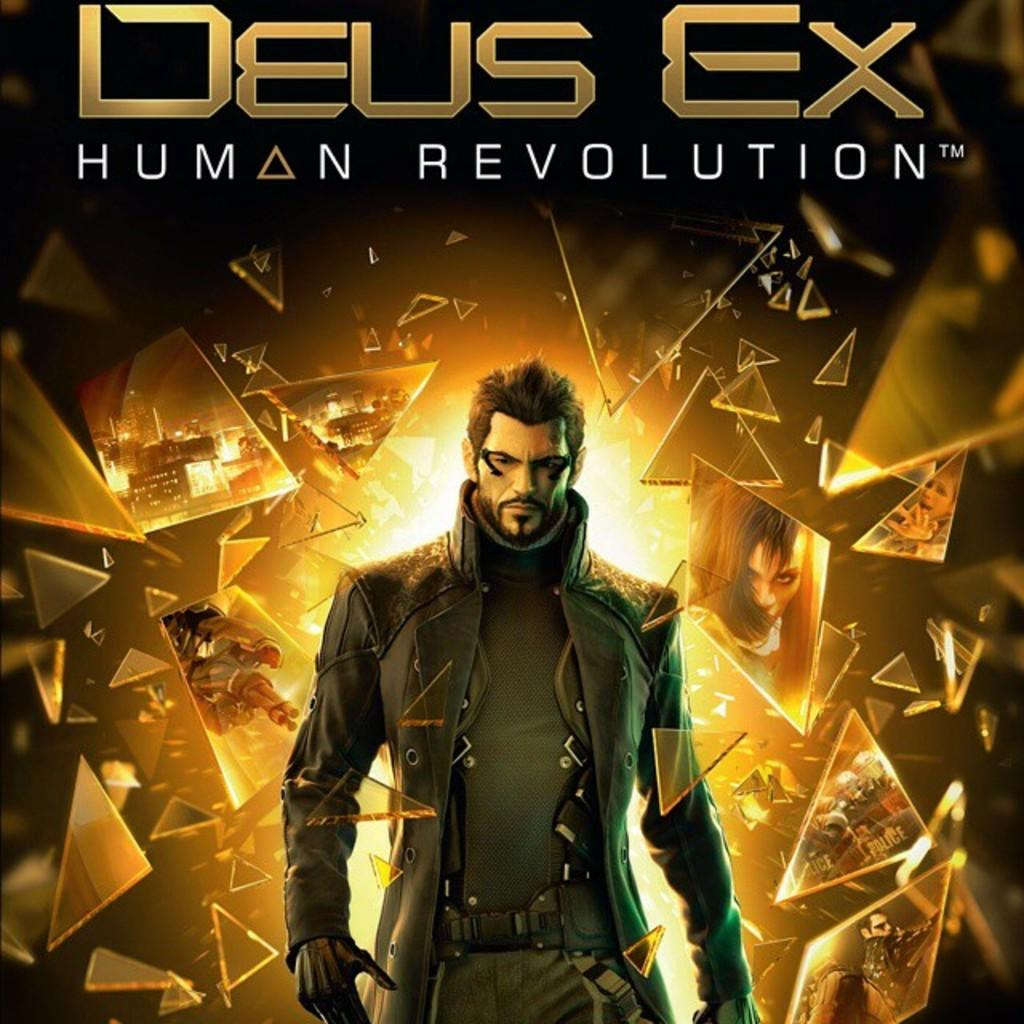<image>
Provide a brief description of the given image. Deus ex human revolution poster with a man in the middle 